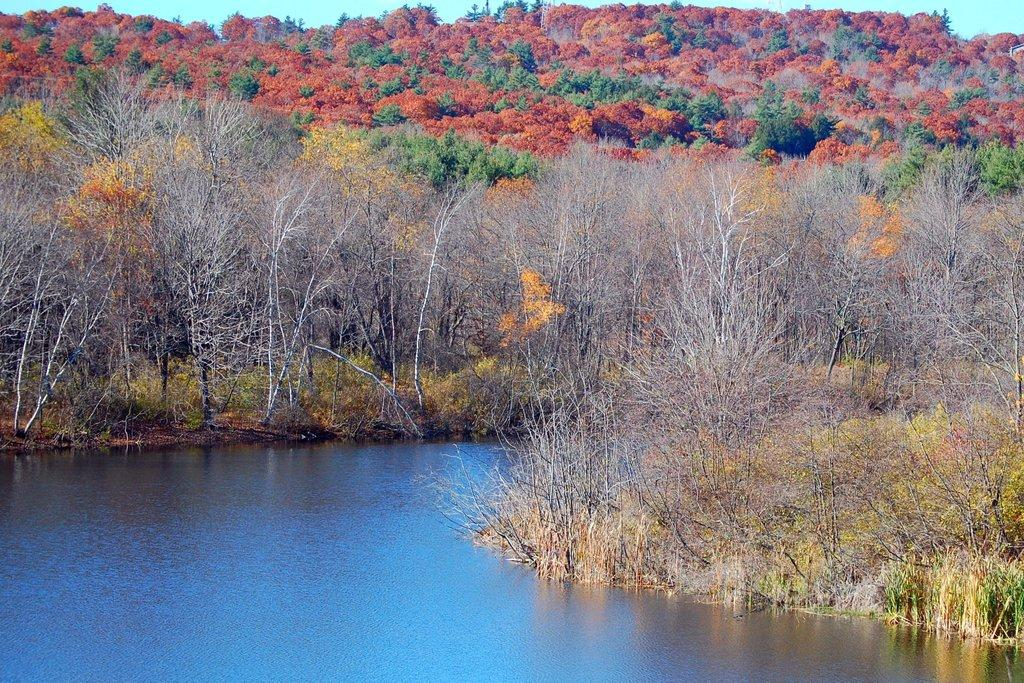What type of natural environment can be seen in the background of the image? There are trees in the background of the image. What is visible at the bottom of the image? There is water and plants visible at the bottom of the image. What part of the natural environment is visible at the top of the image? The sky is visible at the top of the image. Can you see the brain of the person in the image? There is no person present in the image, and therefore no brain can be seen. What is the slope of the hill in the image? There is no hill present in the image, so it is not possible to determine the slope. 